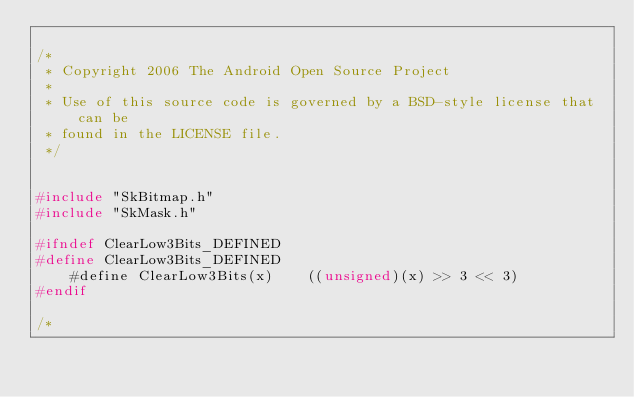Convert code to text. <code><loc_0><loc_0><loc_500><loc_500><_C_>
/*
 * Copyright 2006 The Android Open Source Project
 *
 * Use of this source code is governed by a BSD-style license that can be
 * found in the LICENSE file.
 */


#include "SkBitmap.h"
#include "SkMask.h"

#ifndef ClearLow3Bits_DEFINED
#define ClearLow3Bits_DEFINED
    #define ClearLow3Bits(x)    ((unsigned)(x) >> 3 << 3)
#endif

/*</code> 